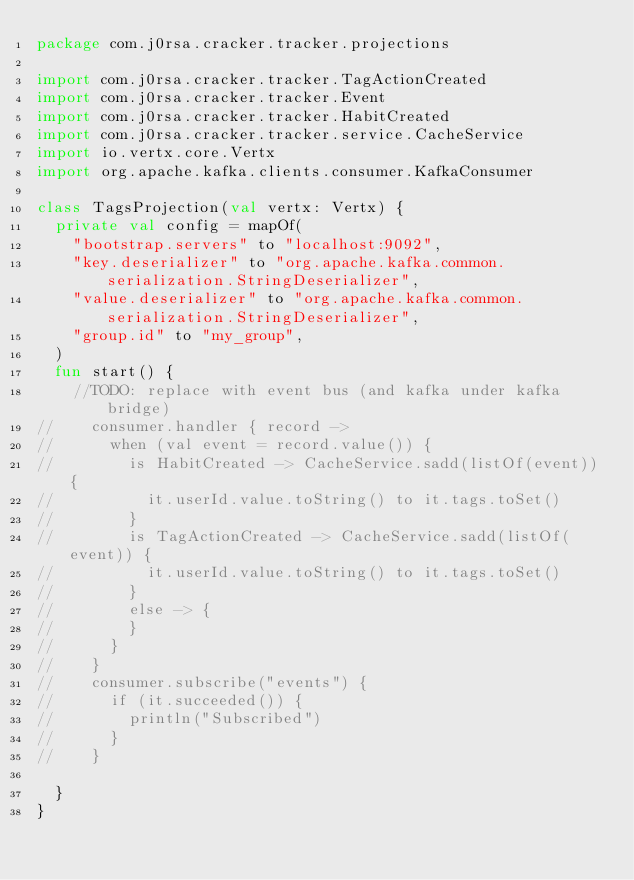<code> <loc_0><loc_0><loc_500><loc_500><_Kotlin_>package com.j0rsa.cracker.tracker.projections

import com.j0rsa.cracker.tracker.TagActionCreated
import com.j0rsa.cracker.tracker.Event
import com.j0rsa.cracker.tracker.HabitCreated
import com.j0rsa.cracker.tracker.service.CacheService
import io.vertx.core.Vertx
import org.apache.kafka.clients.consumer.KafkaConsumer

class TagsProjection(val vertx: Vertx) {
	private val config = mapOf(
		"bootstrap.servers" to "localhost:9092",
		"key.deserializer" to "org.apache.kafka.common.serialization.StringDeserializer",
		"value.deserializer" to "org.apache.kafka.common.serialization.StringDeserializer",
		"group.id" to "my_group",
	)
	fun start() {
		//TODO: replace with event bus (and kafka under kafka bridge)
//		consumer.handler { record ->
//			when (val event = record.value()) {
//				is HabitCreated -> CacheService.sadd(listOf(event)) {
//					it.userId.value.toString() to it.tags.toSet()
//				}
//				is TagActionCreated -> CacheService.sadd(listOf(event)) {
//					it.userId.value.toString() to it.tags.toSet()
//				}
//				else -> {
//				}
//			}
//		}
//		consumer.subscribe("events") {
//			if (it.succeeded()) {
//				println("Subscribed")
//			}
//		}

	}
}</code> 